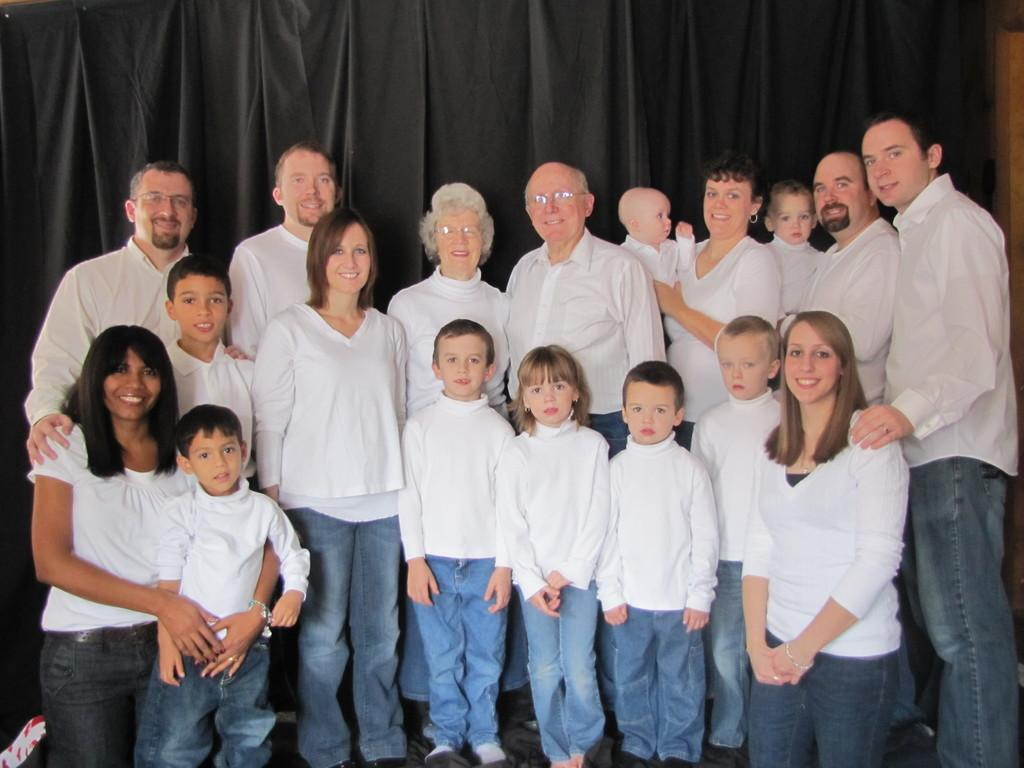What can be seen in the image? There are people standing in the image. What are the people wearing? The people are wearing white dresses. What is visible in the background of the image? There is a curtain in the background of the image. How many pigs are visible in the image? There are no pigs present in the image. What type of shirt is the person in the image wearing? The people in the image are wearing white dresses, not shirts. 